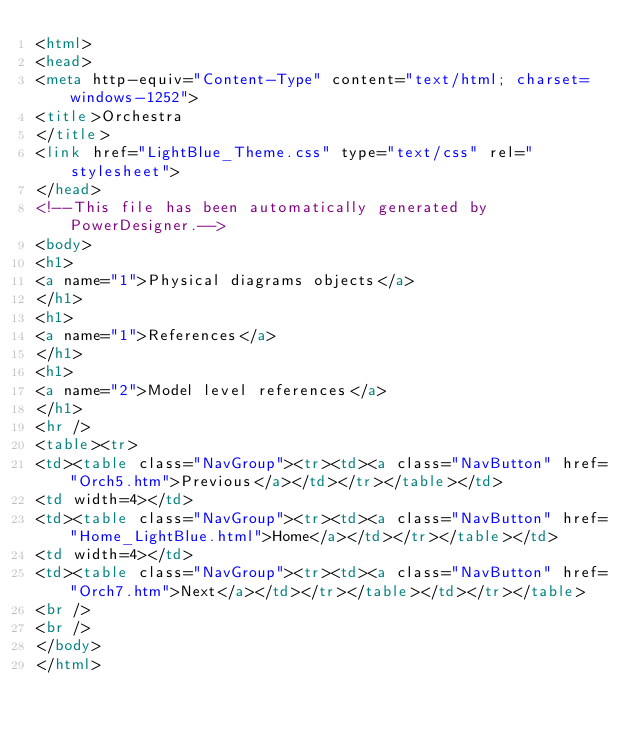Convert code to text. <code><loc_0><loc_0><loc_500><loc_500><_HTML_><html>
<head>
<meta http-equiv="Content-Type" content="text/html; charset=windows-1252">
<title>Orchestra
</title>
<link href="LightBlue_Theme.css" type="text/css" rel="stylesheet">
</head>
<!--This file has been automatically generated by PowerDesigner.-->
<body>
<h1>
<a name="1">Physical diagrams objects</a> 
</h1>
<h1>
<a name="1">References</a> 
</h1>
<h1>
<a name="2">Model level references</a> 
</h1>
<hr />
<table><tr>
<td><table class="NavGroup"><tr><td><a class="NavButton" href="Orch5.htm">Previous</a></td></tr></table></td>
<td width=4></td>
<td><table class="NavGroup"><tr><td><a class="NavButton" href="Home_LightBlue.html">Home</a></td></tr></table></td>
<td width=4></td>
<td><table class="NavGroup"><tr><td><a class="NavButton" href="Orch7.htm">Next</a></td></tr></table></td></tr></table>
<br />
<br />
</body>
</html>
</code> 